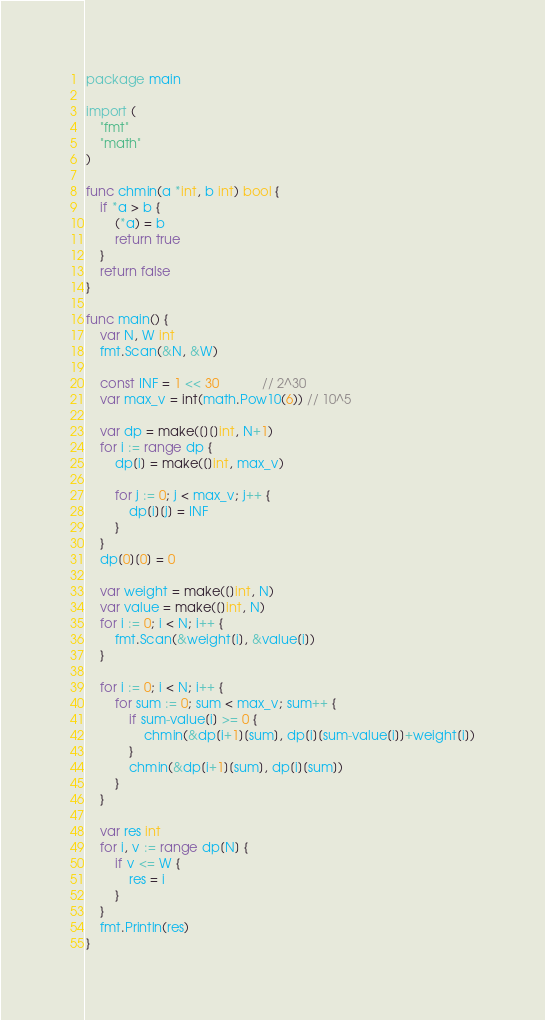Convert code to text. <code><loc_0><loc_0><loc_500><loc_500><_Go_>package main

import (
	"fmt"
	"math"
)

func chmin(a *int, b int) bool {
	if *a > b {
		(*a) = b
		return true
	}
	return false
}

func main() {
	var N, W int
	fmt.Scan(&N, &W)

	const INF = 1 << 30            // 2^30
	var max_v = int(math.Pow10(6)) // 10^5

	var dp = make([][]int, N+1)
	for i := range dp {
		dp[i] = make([]int, max_v)

		for j := 0; j < max_v; j++ {
			dp[i][j] = INF
		}
	}
	dp[0][0] = 0

	var weight = make([]int, N)
	var value = make([]int, N)
	for i := 0; i < N; i++ {
		fmt.Scan(&weight[i], &value[i])
	}

	for i := 0; i < N; i++ {
		for sum := 0; sum < max_v; sum++ {
			if sum-value[i] >= 0 {
				chmin(&dp[i+1][sum], dp[i][sum-value[i]]+weight[i])
			}
			chmin(&dp[i+1][sum], dp[i][sum])
		}
	}

	var res int
	for i, v := range dp[N] {
		if v <= W {
			res = i
		}
	}
	fmt.Println(res)
}</code> 